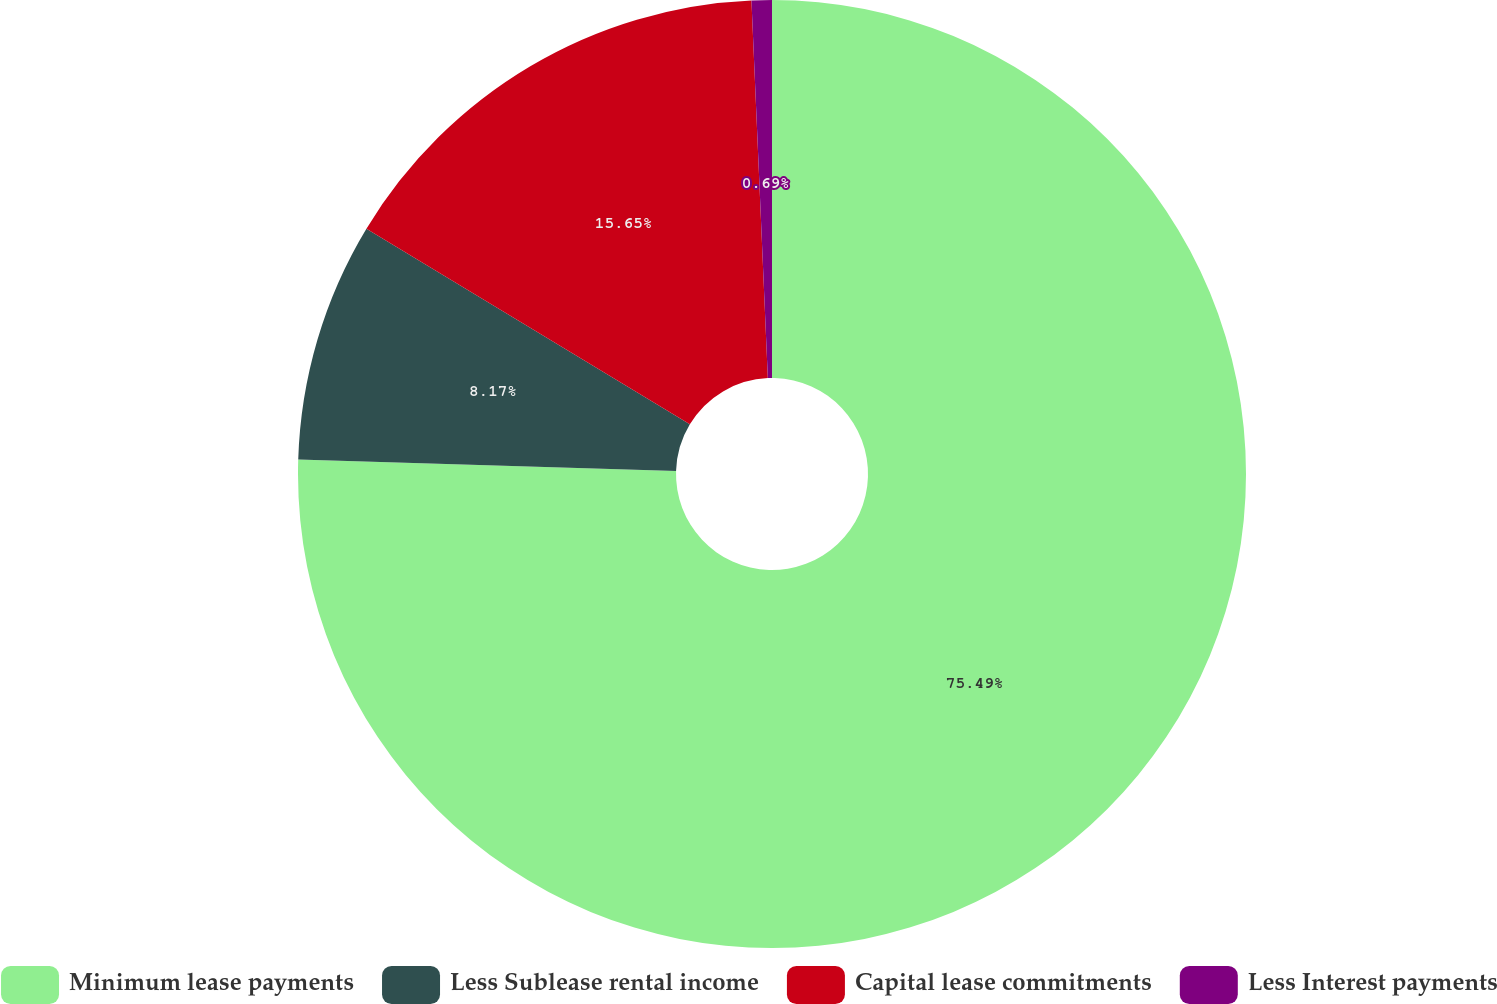Convert chart to OTSL. <chart><loc_0><loc_0><loc_500><loc_500><pie_chart><fcel>Minimum lease payments<fcel>Less Sublease rental income<fcel>Capital lease commitments<fcel>Less Interest payments<nl><fcel>75.48%<fcel>8.17%<fcel>15.65%<fcel>0.69%<nl></chart> 